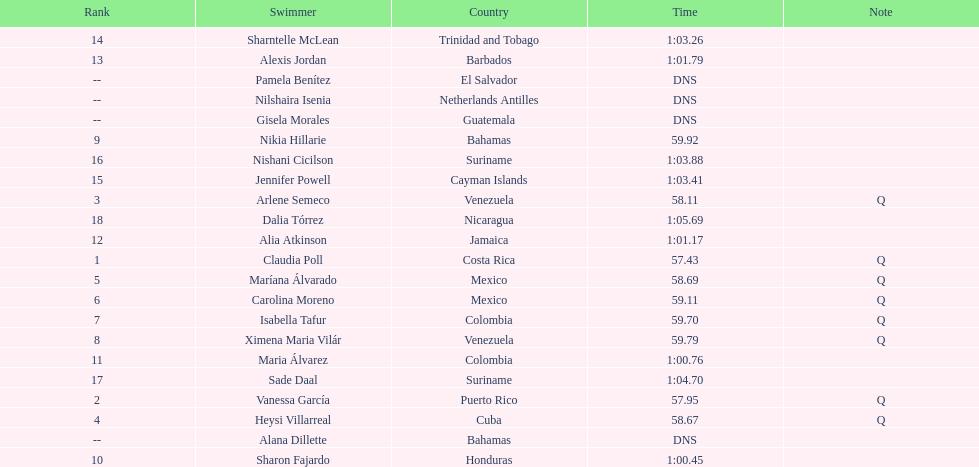How many mexican swimmers ranked in the top 10? 2. 